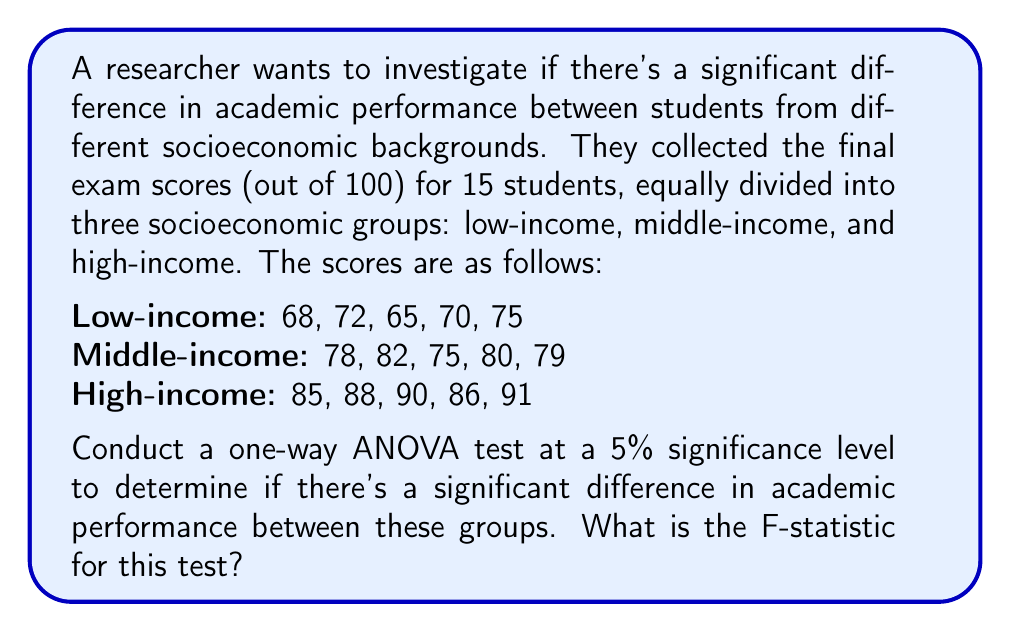Teach me how to tackle this problem. To conduct a one-way ANOVA test, we need to follow these steps:

1. Calculate the mean for each group and the overall mean:
   Low-income mean: $\bar{x}_L = \frac{68 + 72 + 65 + 70 + 75}{5} = 70$
   Middle-income mean: $\bar{x}_M = \frac{78 + 82 + 75 + 80 + 79}{5} = 78.8$
   High-income mean: $\bar{x}_H = \frac{85 + 88 + 90 + 86 + 91}{5} = 88$
   Overall mean: $\bar{x} = \frac{70 + 78.8 + 88}{3} = 78.93$

2. Calculate the Sum of Squares Between groups (SSB):
   $$SSB = n_1(\bar{x}_L - \bar{x})^2 + n_2(\bar{x}_M - \bar{x})^2 + n_3(\bar{x}_H - \bar{x})^2$$
   $$SSB = 5(70 - 78.93)^2 + 5(78.8 - 78.93)^2 + 5(88 - 78.93)^2 = 990.13$$

3. Calculate the Sum of Squares Within groups (SSW):
   $$SSW = \sum_{i=1}^{3}\sum_{j=1}^{5}(x_{ij} - \bar{x}_i)^2$$
   Low-income: $(68-70)^2 + (72-70)^2 + (65-70)^2 + (70-70)^2 + (75-70)^2 = 62$
   Middle-income: $(78-78.8)^2 + (82-78.8)^2 + (75-78.8)^2 + (80-78.8)^2 + (79-78.8)^2 = 26.8$
   High-income: $(85-88)^2 + (88-88)^2 + (90-88)^2 + (86-88)^2 + (91-88)^2 = 30$
   $$SSW = 62 + 26.8 + 30 = 118.8$$

4. Calculate the degrees of freedom:
   Between groups: $df_B = k - 1 = 3 - 1 = 2$ (where k is the number of groups)
   Within groups: $df_W = N - k = 15 - 3 = 12$ (where N is the total number of observations)

5. Calculate the Mean Square Between (MSB) and Mean Square Within (MSW):
   $$MSB = \frac{SSB}{df_B} = \frac{990.13}{2} = 495.065$$
   $$MSW = \frac{SSW}{df_W} = \frac{118.8}{12} = 9.9$$

6. Calculate the F-statistic:
   $$F = \frac{MSB}{MSW} = \frac{495.065}{9.9} = 50.01$$

The F-statistic for this test is 50.01.
Answer: The F-statistic for this one-way ANOVA test is 50.01. 